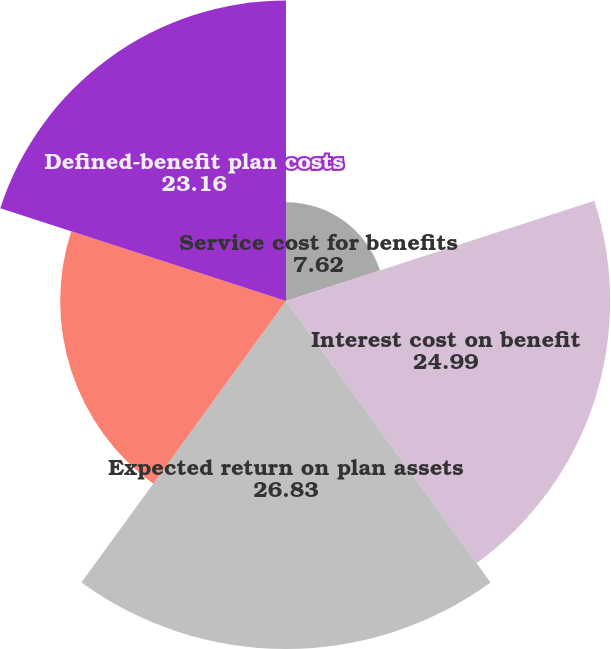<chart> <loc_0><loc_0><loc_500><loc_500><pie_chart><fcel>Service cost for benefits<fcel>Interest cost on benefit<fcel>Expected return on plan assets<fcel>Net amortization and deferral<fcel>Defined-benefit plan costs<nl><fcel>7.62%<fcel>24.99%<fcel>26.83%<fcel>17.41%<fcel>23.16%<nl></chart> 